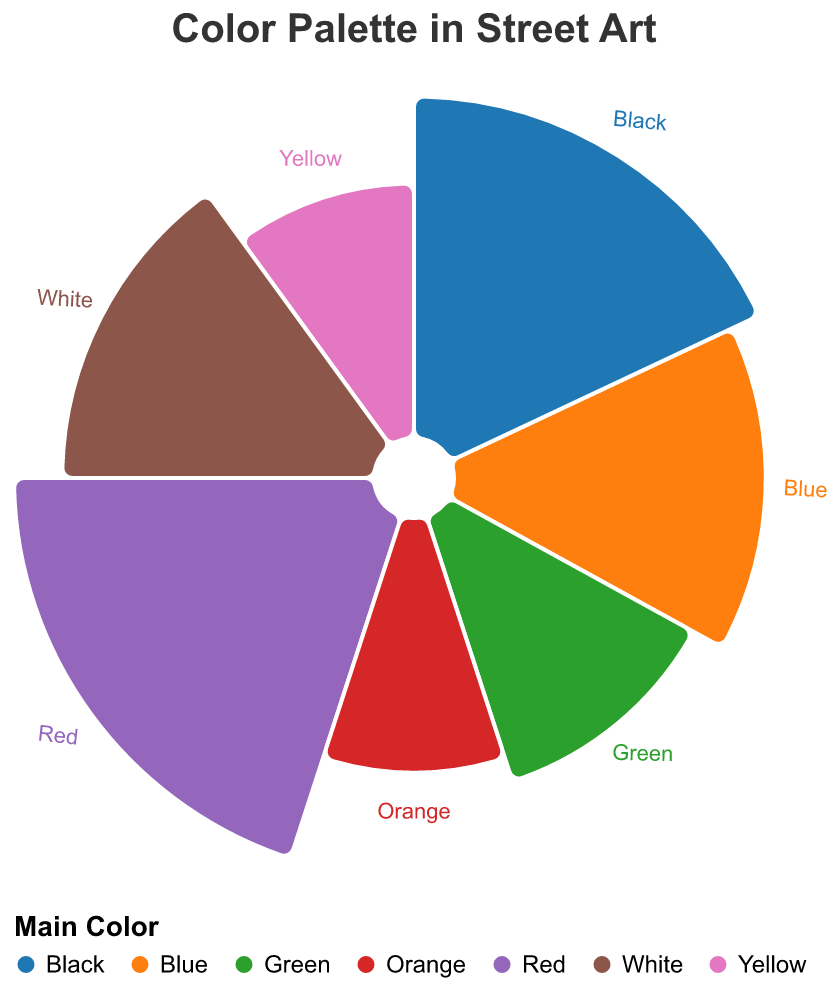Is red the most used color in the street art pieces? By visually inspecting the Polar Chart, we can see that the Red segment is the largest.
Answer: Yes What is the total proportion of the colors used by Shepard Fairey and Jean-Michel Basquiat? Shepard Fairey uses Blue (15%) and Jean-Michel Basquiat uses White (15%). Summing these two proportions gives us 15% + 15% = 30%.
Answer: 30% Which color has a higher proportion: Green or Yellow? By looking at the Polar Chart, the Green segment is larger than the Yellow segment.
Answer: Green What is the title of the Polar Chart? The title is typically displayed at the top of the chart. Inspecting the chart reveals the title.
Answer: Color Palette in Street Art Which two artists use a color proportion of 15%? By examining the Polar Chart's segments and their associated labels, we identify Shepard Fairey (Blue) and Jean-Michel Basquiat (White) both use 15%.
Answer: Shepard Fairey and Jean-Michel Basquiat What is the total proportion of all the colors used in the street art pieces? Summing the proportions of all main colors: Red (20%) + Blue (15%) + Yellow (10%) + Green (12%) + Black (18%) + White (15%) + Orange (10%) = 100%.
Answer: 100% How much more proportion does Banksy use compared to Keith Haring? Banksy uses Red (20%) and Keith Haring uses Yellow (10%). Subtracting these two proportions, we get 20% - 10% = 10%.
Answer: 10% Which color is used by JR and what proportion does it represent? Inspecting the Polar Chart, JR uses Green, which has a proportion of 12%.
Answer: Green, 12% What is the smallest color proportion in the chart and which artists use it? By viewing the smallest segments of the chart, Yellow (10%) and Orange (10%) are the smallest proportions. They are used by Keith Haring (Yellow) and Swoon (Orange).
Answer: Yellow and Orange, 10% 